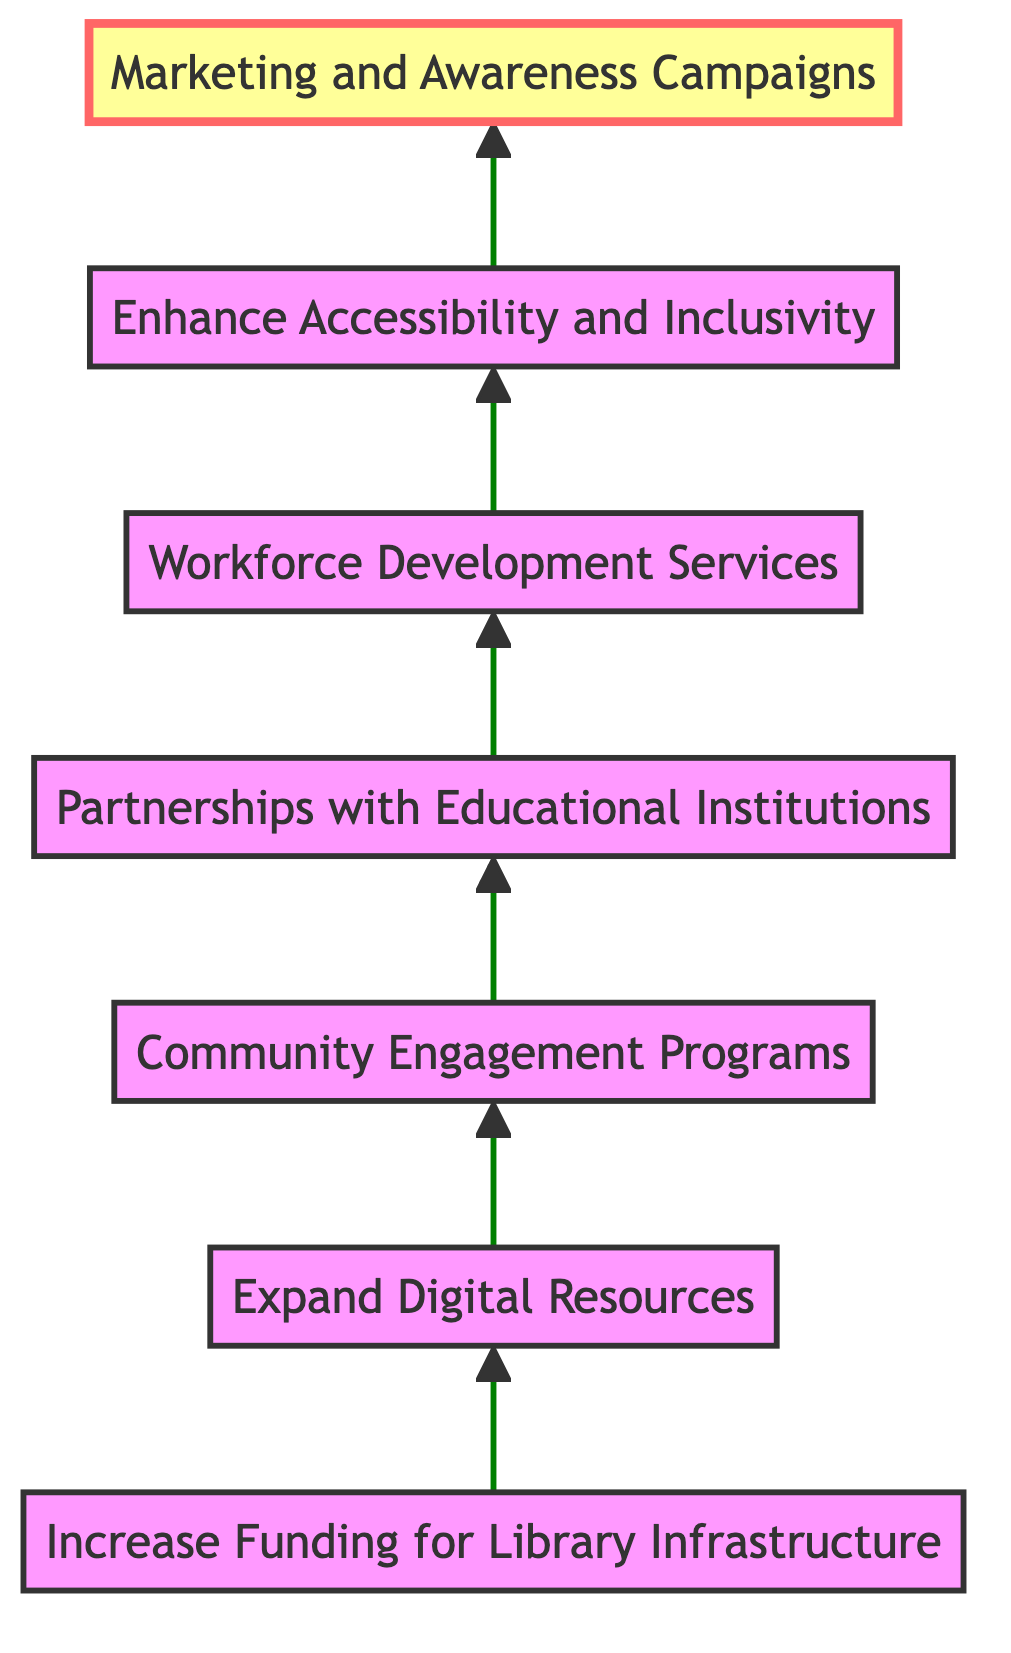What is the final step in the flowchart? The flowchart ends with "Marketing and Awareness Campaigns" as the highest step indicated by the upward arrow at the top.
Answer: Marketing and Awareness Campaigns How many nodes are present in the diagram? The diagram includes seven distinct nodes representing various policy steps to support libraries.
Answer: Seven What is the first step indicated in the flowchart? The first step at the bottom of the diagram is "Increase Funding for Library Infrastructure," which initiates the flow.
Answer: Increase Funding for Library Infrastructure Which two steps are directly connected from "Community Engagement Programs"? Following the flow from "Community Engagement Programs," the next two connected steps are "Partnerships with Educational Institutions" and "Workforce Development Services."
Answer: Partnerships with Educational Institutions, Workforce Development Services What is the relationship between "Expand Digital Resources" and "Marketing and Awareness Campaigns"? "Expand Digital Resources" leads to "Community Engagement Programs," which further leads to "Marketing and Awareness Campaigns" after passing through several other steps, showing a cascading effect of policy steps.
Answer: Cascading effect What is the purpose of the first node in the flowchart? The first node, "Increase Funding for Library Infrastructure," aims to allocate a higher percentage of the municipal budget for library development, critical for establishing foundational support.
Answer: Allocate a higher percentage of the budget What step advises on the inclusivity of libraries? The designated step that focuses on ensuring libraries are accessible to all community members, including those with disabilities, is "Enhance Accessibility and Inclusivity."
Answer: Enhance Accessibility and Inclusivity How many links are there from "Workforce Development Services" to subsequent steps? There is one direct link from "Workforce Development Services" leading to "Enhance Accessibility and Inclusivity," continuing the sequence of policy implementation.
Answer: One What step follows "Partnerships with Educational Institutions"? The next step immediately following "Partnerships with Educational Institutions" is "Workforce Development Services," maintaining the flow of policy focus.
Answer: Workforce Development Services 